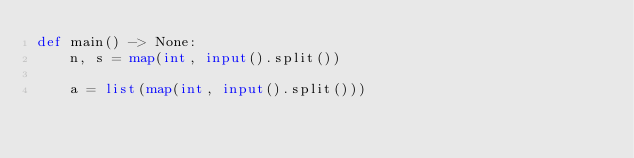Convert code to text. <code><loc_0><loc_0><loc_500><loc_500><_Python_>def main() -> None:
    n, s = map(int, input().split())

    a = list(map(int, input().split()))</code> 